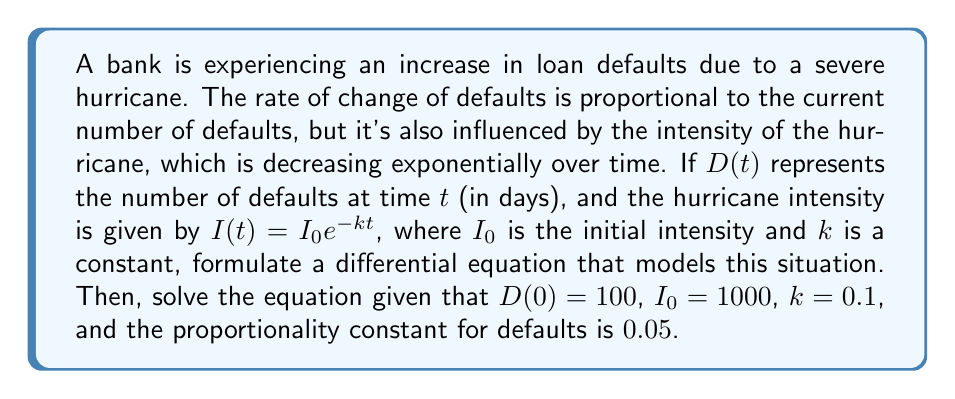Can you solve this math problem? Let's approach this step-by-step:

1) The rate of change of defaults is proportional to the current number of defaults and the hurricane intensity. We can express this as:

   $$\frac{dD}{dt} = aD + bI(t)$$

   where $a$ is the proportionality constant for defaults and $b$ is a constant relating hurricane intensity to defaults.

2) Substituting the given function for $I(t)$:

   $$\frac{dD}{dt} = aD + bI_0e^{-kt}$$

3) We're given $a = 0.05$, $I_0 = 1000$, and $k = 0.1$. Let's assume $b = 0.001$ (this value isn't provided, so we're making an assumption). Now our equation is:

   $$\frac{dD}{dt} = 0.05D + 1000 \cdot 0.001e^{-0.1t} = 0.05D + e^{-0.1t}$$

4) This is a linear first-order differential equation of the form:

   $$\frac{dD}{dt} + P(t)D = Q(t)$$

   where $P(t) = -0.05$ and $Q(t) = e^{-0.1t}$

5) The general solution for this type of equation is:

   $$D = e^{-\int P(t)dt} \left(\int Q(t)e^{\int P(t)dt}dt + C\right)$$

6) Solving:
   
   $\int P(t)dt = \int -0.05dt = -0.05t$
   
   $e^{\int P(t)dt} = e^{-0.05t}$
   
   $\int Q(t)e^{\int P(t)dt}dt = \int e^{-0.1t}e^{-0.05t}dt = \int e^{-0.15t}dt = -\frac{1}{0.15}e^{-0.15t} + C_1$

7) Therefore, the general solution is:

   $$D = e^{0.05t}\left(-\frac{1}{0.15}e^{-0.15t} + C\right) = -\frac{1}{0.15}e^{-0.1t} + Ce^{0.05t}$$

8) Using the initial condition $D(0) = 100$:

   $$100 = -\frac{1}{0.15} + C$$
   $$C = 100 + \frac{1}{0.15} \approx 106.67$$

9) Therefore, the particular solution is:

   $$D(t) = -\frac{1}{0.15}e^{-0.1t} + 106.67e^{0.05t}$$
Answer: The differential equation modeling the situation is:

$$\frac{dD}{dt} = 0.05D + e^{-0.1t}$$

The solution, given the initial conditions, is:

$$D(t) = -\frac{1}{0.15}e^{-0.1t} + 106.67e^{0.05t}$$ 